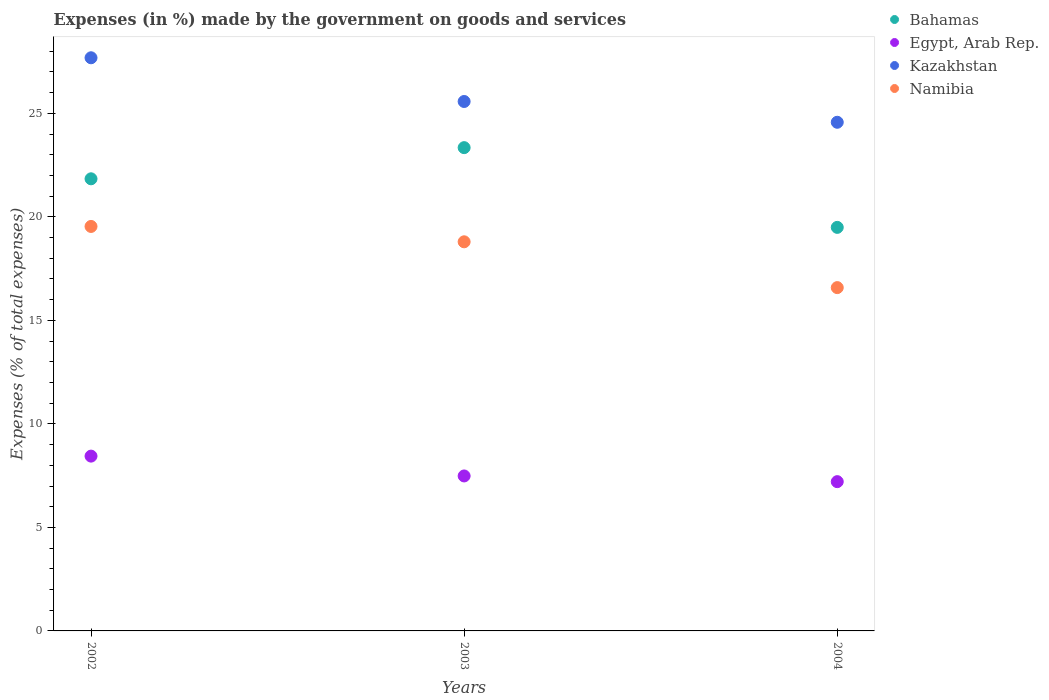Is the number of dotlines equal to the number of legend labels?
Make the answer very short. Yes. What is the percentage of expenses made by the government on goods and services in Kazakhstan in 2002?
Your answer should be very brief. 27.68. Across all years, what is the maximum percentage of expenses made by the government on goods and services in Egypt, Arab Rep.?
Provide a short and direct response. 8.44. Across all years, what is the minimum percentage of expenses made by the government on goods and services in Kazakhstan?
Your response must be concise. 24.57. In which year was the percentage of expenses made by the government on goods and services in Bahamas minimum?
Keep it short and to the point. 2004. What is the total percentage of expenses made by the government on goods and services in Bahamas in the graph?
Your response must be concise. 64.67. What is the difference between the percentage of expenses made by the government on goods and services in Kazakhstan in 2002 and that in 2004?
Offer a very short reply. 3.12. What is the difference between the percentage of expenses made by the government on goods and services in Namibia in 2004 and the percentage of expenses made by the government on goods and services in Egypt, Arab Rep. in 2002?
Ensure brevity in your answer.  8.14. What is the average percentage of expenses made by the government on goods and services in Bahamas per year?
Your answer should be compact. 21.56. In the year 2004, what is the difference between the percentage of expenses made by the government on goods and services in Egypt, Arab Rep. and percentage of expenses made by the government on goods and services in Namibia?
Make the answer very short. -9.37. What is the ratio of the percentage of expenses made by the government on goods and services in Egypt, Arab Rep. in 2002 to that in 2004?
Your response must be concise. 1.17. Is the percentage of expenses made by the government on goods and services in Kazakhstan in 2003 less than that in 2004?
Your response must be concise. No. What is the difference between the highest and the second highest percentage of expenses made by the government on goods and services in Bahamas?
Provide a short and direct response. 1.51. What is the difference between the highest and the lowest percentage of expenses made by the government on goods and services in Egypt, Arab Rep.?
Offer a terse response. 1.23. In how many years, is the percentage of expenses made by the government on goods and services in Kazakhstan greater than the average percentage of expenses made by the government on goods and services in Kazakhstan taken over all years?
Provide a succinct answer. 1. Is it the case that in every year, the sum of the percentage of expenses made by the government on goods and services in Egypt, Arab Rep. and percentage of expenses made by the government on goods and services in Namibia  is greater than the sum of percentage of expenses made by the government on goods and services in Bahamas and percentage of expenses made by the government on goods and services in Kazakhstan?
Your answer should be compact. No. Is the percentage of expenses made by the government on goods and services in Namibia strictly less than the percentage of expenses made by the government on goods and services in Bahamas over the years?
Make the answer very short. Yes. How many years are there in the graph?
Keep it short and to the point. 3. What is the difference between two consecutive major ticks on the Y-axis?
Make the answer very short. 5. Where does the legend appear in the graph?
Your answer should be compact. Top right. How are the legend labels stacked?
Provide a short and direct response. Vertical. What is the title of the graph?
Ensure brevity in your answer.  Expenses (in %) made by the government on goods and services. What is the label or title of the Y-axis?
Your answer should be compact. Expenses (% of total expenses). What is the Expenses (% of total expenses) in Bahamas in 2002?
Make the answer very short. 21.84. What is the Expenses (% of total expenses) in Egypt, Arab Rep. in 2002?
Your answer should be very brief. 8.44. What is the Expenses (% of total expenses) in Kazakhstan in 2002?
Your answer should be compact. 27.68. What is the Expenses (% of total expenses) of Namibia in 2002?
Give a very brief answer. 19.54. What is the Expenses (% of total expenses) in Bahamas in 2003?
Ensure brevity in your answer.  23.34. What is the Expenses (% of total expenses) in Egypt, Arab Rep. in 2003?
Offer a terse response. 7.49. What is the Expenses (% of total expenses) in Kazakhstan in 2003?
Ensure brevity in your answer.  25.57. What is the Expenses (% of total expenses) in Namibia in 2003?
Ensure brevity in your answer.  18.8. What is the Expenses (% of total expenses) of Bahamas in 2004?
Give a very brief answer. 19.49. What is the Expenses (% of total expenses) of Egypt, Arab Rep. in 2004?
Offer a terse response. 7.21. What is the Expenses (% of total expenses) of Kazakhstan in 2004?
Keep it short and to the point. 24.57. What is the Expenses (% of total expenses) of Namibia in 2004?
Ensure brevity in your answer.  16.58. Across all years, what is the maximum Expenses (% of total expenses) of Bahamas?
Your answer should be compact. 23.34. Across all years, what is the maximum Expenses (% of total expenses) of Egypt, Arab Rep.?
Ensure brevity in your answer.  8.44. Across all years, what is the maximum Expenses (% of total expenses) of Kazakhstan?
Your answer should be compact. 27.68. Across all years, what is the maximum Expenses (% of total expenses) in Namibia?
Offer a very short reply. 19.54. Across all years, what is the minimum Expenses (% of total expenses) in Bahamas?
Your answer should be very brief. 19.49. Across all years, what is the minimum Expenses (% of total expenses) of Egypt, Arab Rep.?
Your answer should be very brief. 7.21. Across all years, what is the minimum Expenses (% of total expenses) of Kazakhstan?
Ensure brevity in your answer.  24.57. Across all years, what is the minimum Expenses (% of total expenses) in Namibia?
Your answer should be compact. 16.58. What is the total Expenses (% of total expenses) of Bahamas in the graph?
Give a very brief answer. 64.67. What is the total Expenses (% of total expenses) in Egypt, Arab Rep. in the graph?
Keep it short and to the point. 23.14. What is the total Expenses (% of total expenses) of Kazakhstan in the graph?
Provide a succinct answer. 77.83. What is the total Expenses (% of total expenses) in Namibia in the graph?
Keep it short and to the point. 54.91. What is the difference between the Expenses (% of total expenses) of Bahamas in 2002 and that in 2003?
Offer a terse response. -1.51. What is the difference between the Expenses (% of total expenses) of Egypt, Arab Rep. in 2002 and that in 2003?
Your answer should be compact. 0.96. What is the difference between the Expenses (% of total expenses) in Kazakhstan in 2002 and that in 2003?
Your answer should be compact. 2.11. What is the difference between the Expenses (% of total expenses) of Namibia in 2002 and that in 2003?
Your answer should be compact. 0.74. What is the difference between the Expenses (% of total expenses) of Bahamas in 2002 and that in 2004?
Keep it short and to the point. 2.35. What is the difference between the Expenses (% of total expenses) of Egypt, Arab Rep. in 2002 and that in 2004?
Offer a terse response. 1.23. What is the difference between the Expenses (% of total expenses) in Kazakhstan in 2002 and that in 2004?
Provide a short and direct response. 3.12. What is the difference between the Expenses (% of total expenses) in Namibia in 2002 and that in 2004?
Keep it short and to the point. 2.95. What is the difference between the Expenses (% of total expenses) of Bahamas in 2003 and that in 2004?
Provide a succinct answer. 3.85. What is the difference between the Expenses (% of total expenses) in Egypt, Arab Rep. in 2003 and that in 2004?
Offer a terse response. 0.28. What is the difference between the Expenses (% of total expenses) in Kazakhstan in 2003 and that in 2004?
Your answer should be very brief. 1. What is the difference between the Expenses (% of total expenses) in Namibia in 2003 and that in 2004?
Provide a succinct answer. 2.21. What is the difference between the Expenses (% of total expenses) in Bahamas in 2002 and the Expenses (% of total expenses) in Egypt, Arab Rep. in 2003?
Your answer should be compact. 14.35. What is the difference between the Expenses (% of total expenses) of Bahamas in 2002 and the Expenses (% of total expenses) of Kazakhstan in 2003?
Offer a terse response. -3.73. What is the difference between the Expenses (% of total expenses) in Bahamas in 2002 and the Expenses (% of total expenses) in Namibia in 2003?
Your answer should be very brief. 3.04. What is the difference between the Expenses (% of total expenses) of Egypt, Arab Rep. in 2002 and the Expenses (% of total expenses) of Kazakhstan in 2003?
Make the answer very short. -17.13. What is the difference between the Expenses (% of total expenses) in Egypt, Arab Rep. in 2002 and the Expenses (% of total expenses) in Namibia in 2003?
Keep it short and to the point. -10.35. What is the difference between the Expenses (% of total expenses) of Kazakhstan in 2002 and the Expenses (% of total expenses) of Namibia in 2003?
Provide a succinct answer. 8.89. What is the difference between the Expenses (% of total expenses) in Bahamas in 2002 and the Expenses (% of total expenses) in Egypt, Arab Rep. in 2004?
Provide a succinct answer. 14.63. What is the difference between the Expenses (% of total expenses) in Bahamas in 2002 and the Expenses (% of total expenses) in Kazakhstan in 2004?
Offer a very short reply. -2.73. What is the difference between the Expenses (% of total expenses) of Bahamas in 2002 and the Expenses (% of total expenses) of Namibia in 2004?
Your answer should be compact. 5.26. What is the difference between the Expenses (% of total expenses) of Egypt, Arab Rep. in 2002 and the Expenses (% of total expenses) of Kazakhstan in 2004?
Ensure brevity in your answer.  -16.13. What is the difference between the Expenses (% of total expenses) in Egypt, Arab Rep. in 2002 and the Expenses (% of total expenses) in Namibia in 2004?
Make the answer very short. -8.14. What is the difference between the Expenses (% of total expenses) in Kazakhstan in 2002 and the Expenses (% of total expenses) in Namibia in 2004?
Provide a short and direct response. 11.1. What is the difference between the Expenses (% of total expenses) of Bahamas in 2003 and the Expenses (% of total expenses) of Egypt, Arab Rep. in 2004?
Make the answer very short. 16.13. What is the difference between the Expenses (% of total expenses) in Bahamas in 2003 and the Expenses (% of total expenses) in Kazakhstan in 2004?
Your response must be concise. -1.23. What is the difference between the Expenses (% of total expenses) of Bahamas in 2003 and the Expenses (% of total expenses) of Namibia in 2004?
Ensure brevity in your answer.  6.76. What is the difference between the Expenses (% of total expenses) in Egypt, Arab Rep. in 2003 and the Expenses (% of total expenses) in Kazakhstan in 2004?
Your answer should be compact. -17.08. What is the difference between the Expenses (% of total expenses) of Egypt, Arab Rep. in 2003 and the Expenses (% of total expenses) of Namibia in 2004?
Provide a succinct answer. -9.1. What is the difference between the Expenses (% of total expenses) of Kazakhstan in 2003 and the Expenses (% of total expenses) of Namibia in 2004?
Your answer should be compact. 8.99. What is the average Expenses (% of total expenses) in Bahamas per year?
Keep it short and to the point. 21.56. What is the average Expenses (% of total expenses) in Egypt, Arab Rep. per year?
Give a very brief answer. 7.71. What is the average Expenses (% of total expenses) of Kazakhstan per year?
Make the answer very short. 25.94. What is the average Expenses (% of total expenses) in Namibia per year?
Your answer should be compact. 18.3. In the year 2002, what is the difference between the Expenses (% of total expenses) in Bahamas and Expenses (% of total expenses) in Egypt, Arab Rep.?
Provide a succinct answer. 13.39. In the year 2002, what is the difference between the Expenses (% of total expenses) in Bahamas and Expenses (% of total expenses) in Kazakhstan?
Offer a very short reply. -5.85. In the year 2002, what is the difference between the Expenses (% of total expenses) in Bahamas and Expenses (% of total expenses) in Namibia?
Provide a succinct answer. 2.3. In the year 2002, what is the difference between the Expenses (% of total expenses) in Egypt, Arab Rep. and Expenses (% of total expenses) in Kazakhstan?
Offer a terse response. -19.24. In the year 2002, what is the difference between the Expenses (% of total expenses) of Egypt, Arab Rep. and Expenses (% of total expenses) of Namibia?
Give a very brief answer. -11.09. In the year 2002, what is the difference between the Expenses (% of total expenses) of Kazakhstan and Expenses (% of total expenses) of Namibia?
Offer a very short reply. 8.15. In the year 2003, what is the difference between the Expenses (% of total expenses) of Bahamas and Expenses (% of total expenses) of Egypt, Arab Rep.?
Offer a terse response. 15.86. In the year 2003, what is the difference between the Expenses (% of total expenses) of Bahamas and Expenses (% of total expenses) of Kazakhstan?
Provide a succinct answer. -2.23. In the year 2003, what is the difference between the Expenses (% of total expenses) of Bahamas and Expenses (% of total expenses) of Namibia?
Ensure brevity in your answer.  4.55. In the year 2003, what is the difference between the Expenses (% of total expenses) in Egypt, Arab Rep. and Expenses (% of total expenses) in Kazakhstan?
Your answer should be compact. -18.09. In the year 2003, what is the difference between the Expenses (% of total expenses) of Egypt, Arab Rep. and Expenses (% of total expenses) of Namibia?
Your answer should be very brief. -11.31. In the year 2003, what is the difference between the Expenses (% of total expenses) of Kazakhstan and Expenses (% of total expenses) of Namibia?
Offer a terse response. 6.78. In the year 2004, what is the difference between the Expenses (% of total expenses) in Bahamas and Expenses (% of total expenses) in Egypt, Arab Rep.?
Keep it short and to the point. 12.28. In the year 2004, what is the difference between the Expenses (% of total expenses) of Bahamas and Expenses (% of total expenses) of Kazakhstan?
Provide a short and direct response. -5.08. In the year 2004, what is the difference between the Expenses (% of total expenses) in Bahamas and Expenses (% of total expenses) in Namibia?
Keep it short and to the point. 2.91. In the year 2004, what is the difference between the Expenses (% of total expenses) of Egypt, Arab Rep. and Expenses (% of total expenses) of Kazakhstan?
Provide a short and direct response. -17.36. In the year 2004, what is the difference between the Expenses (% of total expenses) of Egypt, Arab Rep. and Expenses (% of total expenses) of Namibia?
Offer a terse response. -9.37. In the year 2004, what is the difference between the Expenses (% of total expenses) of Kazakhstan and Expenses (% of total expenses) of Namibia?
Ensure brevity in your answer.  7.99. What is the ratio of the Expenses (% of total expenses) in Bahamas in 2002 to that in 2003?
Ensure brevity in your answer.  0.94. What is the ratio of the Expenses (% of total expenses) of Egypt, Arab Rep. in 2002 to that in 2003?
Give a very brief answer. 1.13. What is the ratio of the Expenses (% of total expenses) of Kazakhstan in 2002 to that in 2003?
Your answer should be very brief. 1.08. What is the ratio of the Expenses (% of total expenses) of Namibia in 2002 to that in 2003?
Keep it short and to the point. 1.04. What is the ratio of the Expenses (% of total expenses) in Bahamas in 2002 to that in 2004?
Your response must be concise. 1.12. What is the ratio of the Expenses (% of total expenses) in Egypt, Arab Rep. in 2002 to that in 2004?
Make the answer very short. 1.17. What is the ratio of the Expenses (% of total expenses) in Kazakhstan in 2002 to that in 2004?
Offer a very short reply. 1.13. What is the ratio of the Expenses (% of total expenses) of Namibia in 2002 to that in 2004?
Ensure brevity in your answer.  1.18. What is the ratio of the Expenses (% of total expenses) in Bahamas in 2003 to that in 2004?
Keep it short and to the point. 1.2. What is the ratio of the Expenses (% of total expenses) of Egypt, Arab Rep. in 2003 to that in 2004?
Your answer should be very brief. 1.04. What is the ratio of the Expenses (% of total expenses) in Kazakhstan in 2003 to that in 2004?
Your response must be concise. 1.04. What is the ratio of the Expenses (% of total expenses) in Namibia in 2003 to that in 2004?
Make the answer very short. 1.13. What is the difference between the highest and the second highest Expenses (% of total expenses) of Bahamas?
Your answer should be compact. 1.51. What is the difference between the highest and the second highest Expenses (% of total expenses) of Egypt, Arab Rep.?
Provide a succinct answer. 0.96. What is the difference between the highest and the second highest Expenses (% of total expenses) in Kazakhstan?
Keep it short and to the point. 2.11. What is the difference between the highest and the second highest Expenses (% of total expenses) in Namibia?
Ensure brevity in your answer.  0.74. What is the difference between the highest and the lowest Expenses (% of total expenses) of Bahamas?
Your answer should be compact. 3.85. What is the difference between the highest and the lowest Expenses (% of total expenses) in Egypt, Arab Rep.?
Make the answer very short. 1.23. What is the difference between the highest and the lowest Expenses (% of total expenses) in Kazakhstan?
Provide a succinct answer. 3.12. What is the difference between the highest and the lowest Expenses (% of total expenses) of Namibia?
Give a very brief answer. 2.95. 